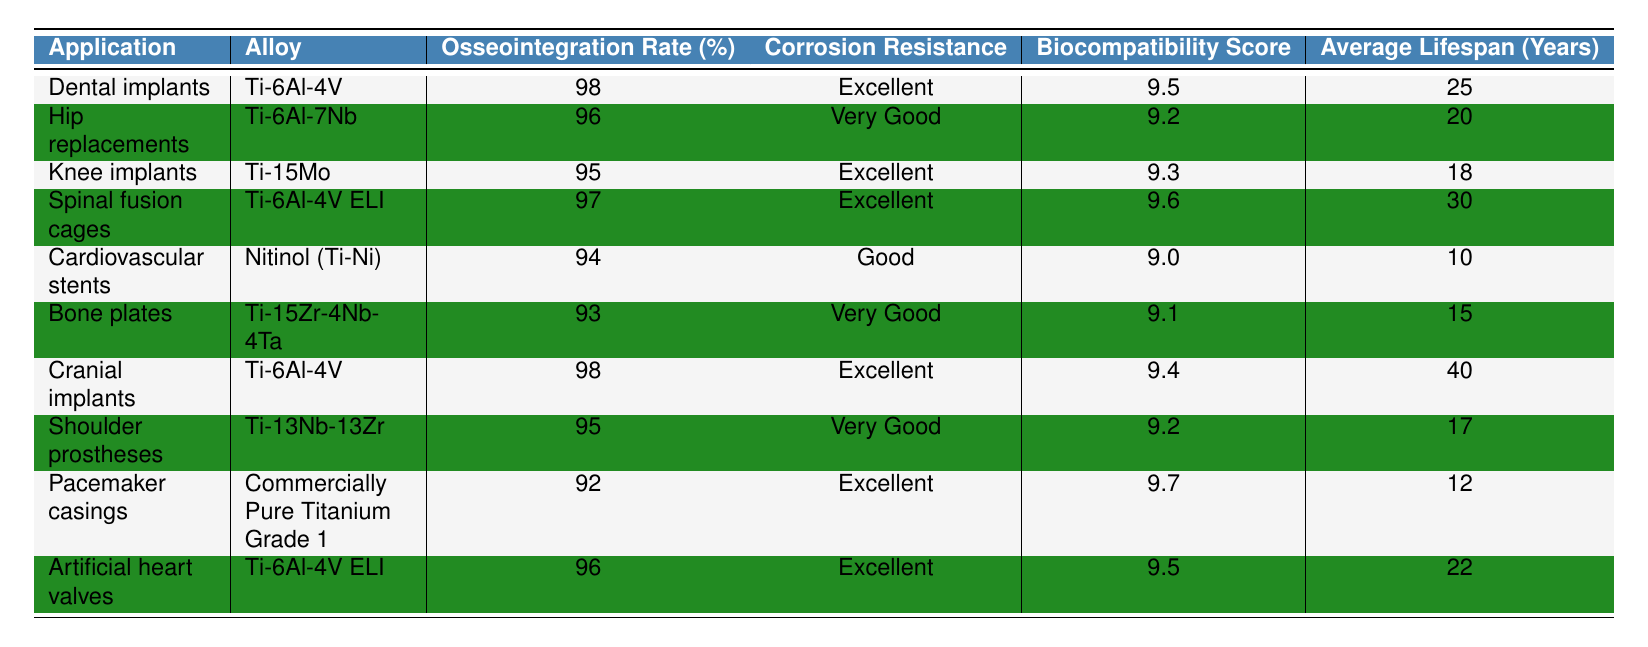What is the osseointegration rate of dental implants? The osseointegration rate for dental implants, which uses the Ti-6Al-4V alloy, is listed in the table as 98%.
Answer: 98% Which titanium alloy has the highest average lifespan? The cranial implants made from Ti-6Al-4V have the highest average lifespan listed in the table at 40 years.
Answer: Ti-6Al-4V What is the corrosion resistance of hip replacements? The table describes the corrosion resistance of hip replacements, made from Ti-6Al-7Nb, as "Very Good".
Answer: Very Good How many applications of titanium have an osseointegration rate of 95% or higher? The table shows that there are 5 applications with an osseointegration rate of 95% or higher: dental implants, hip replacements, spinal fusion cages, cranial implants, and artificial heart valves.
Answer: 5 Is the biocompatibility score for cardiovascular stents higher than 9.3? The biocompatibility score for cardiovascular stents is 9.0, which is lower than 9.3, so the answer is false.
Answer: No What is the average biocompatibility score for alloys used in knee implants and shoulder prostheses? The biocompatibility score for knee implants is 9.3 and for shoulder prostheses is 9.2. The average is (9.3 + 9.2) / 2 = 9.25.
Answer: 9.25 Compare the corrosion resistance between knee implants and bone plates. Is it different? Knee implants have "Excellent" corrosion resistance while bone plates have "Very Good". Since "Excellent" is better than "Very Good", they are different.
Answer: Yes What is the difference in average lifespan between cranial implants and cardiovascular stents? Cranial implants have an average lifespan of 40 years, and cardiovascular stents have 10 years. The difference is 40 - 10 = 30 years.
Answer: 30 years Which application has both the highest osseointegration rate and the highest biocompatibility score? Cranial implants have the highest osseointegration rate of 98% and a high biocompatibility score of 9.4. No other application matches these two criteria.
Answer: Cranial implants Which titanium alloy used in artificial heart valves has a lower osseointegration rate compared to dental implants? The titanium alloy used in artificial heart valves, Ti-6Al-4V ELI, has an osseointegration rate of 96%, which is lower than the 98% for dental implants (Ti-6Al-4V).
Answer: Yes 